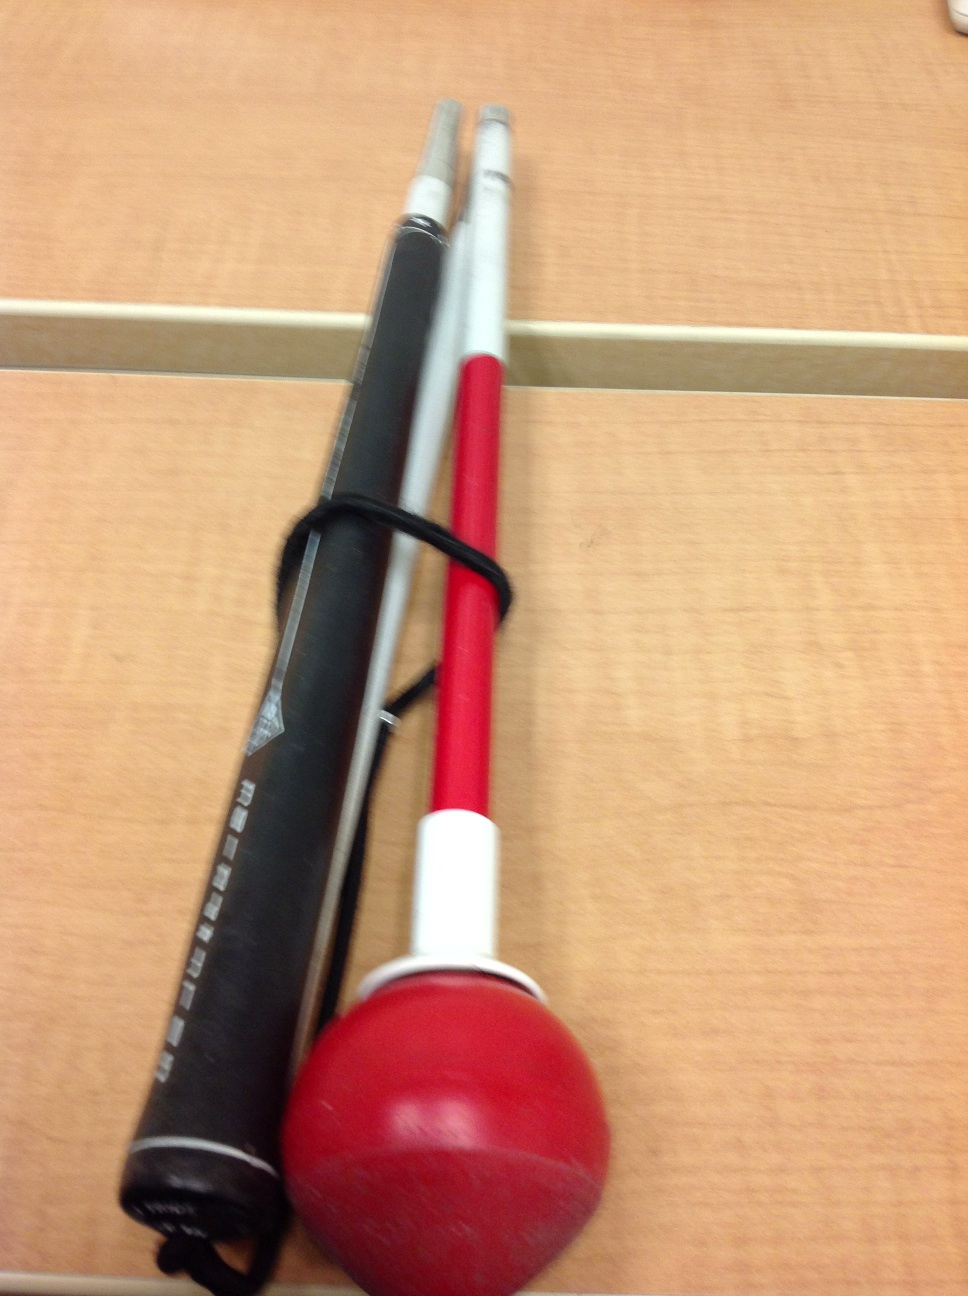What is this? This is a swing training device, likely designed to improve a batter's swing in sports such as baseball or softball. By attaching it to the bat and practicing swings, the batter can work on their hitting mechanics, speed, and power. 